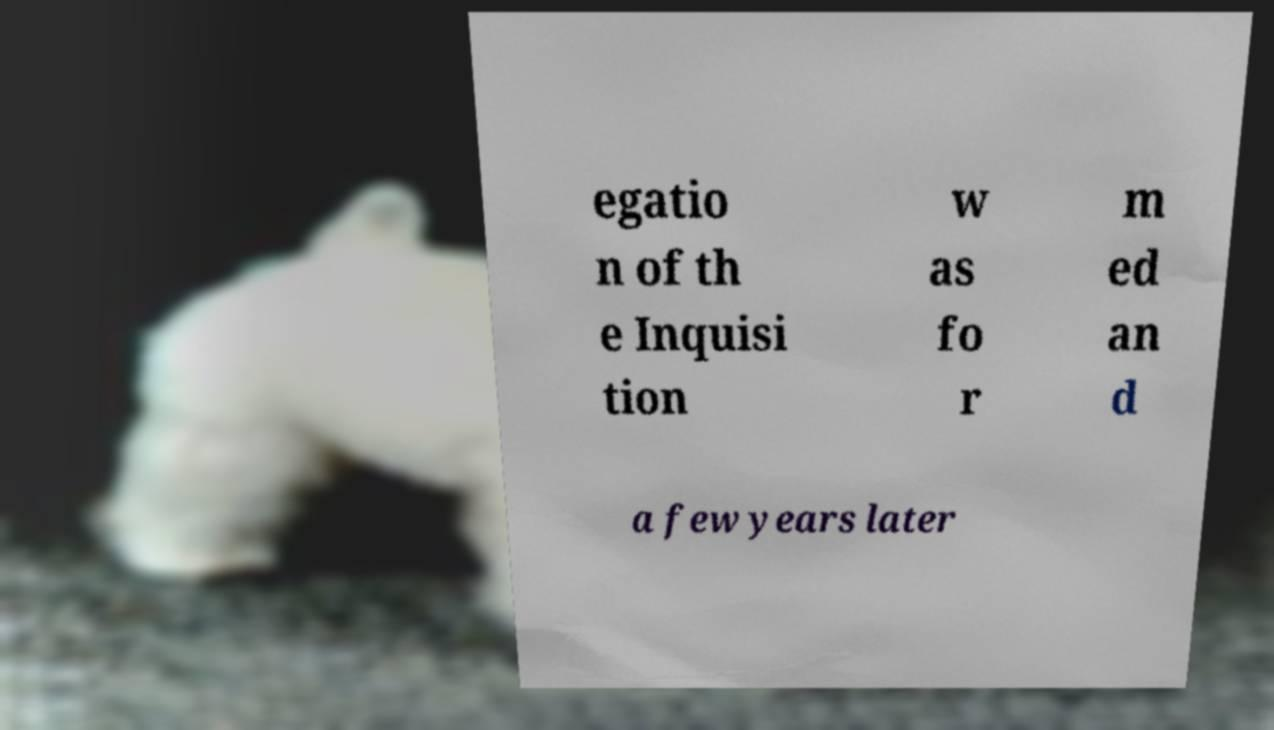Could you extract and type out the text from this image? egatio n of th e Inquisi tion w as fo r m ed an d a few years later 